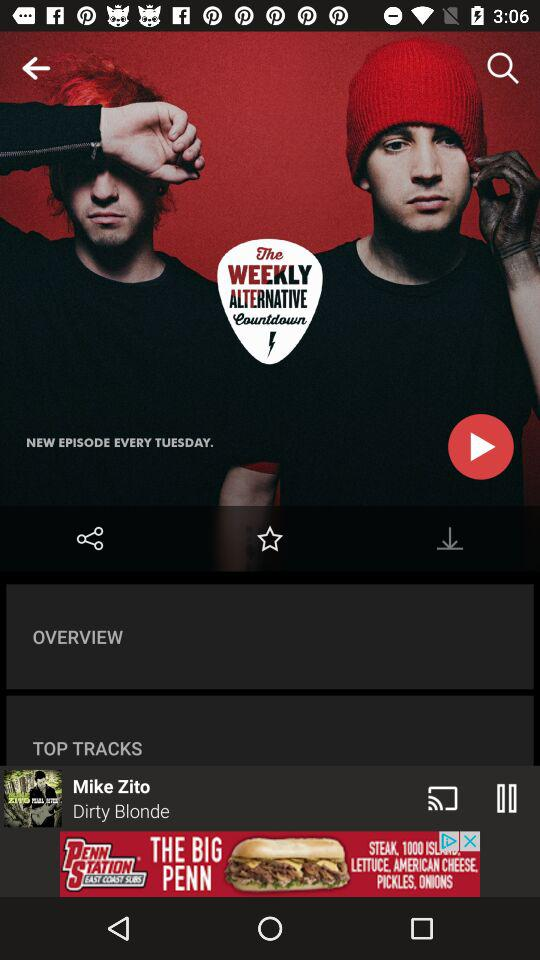How many more top tracks than overview items are there?
Answer the question using a single word or phrase. 1 